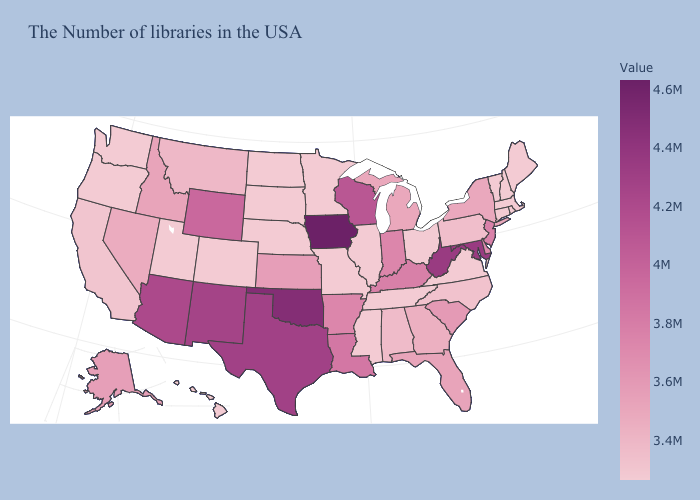Does the map have missing data?
Answer briefly. No. Among the states that border Wyoming , which have the highest value?
Write a very short answer. Idaho. Which states hav the highest value in the Northeast?
Be succinct. New Jersey. Which states have the highest value in the USA?
Be succinct. Iowa. Does the map have missing data?
Short answer required. No. Among the states that border Indiana , does Kentucky have the highest value?
Short answer required. Yes. 